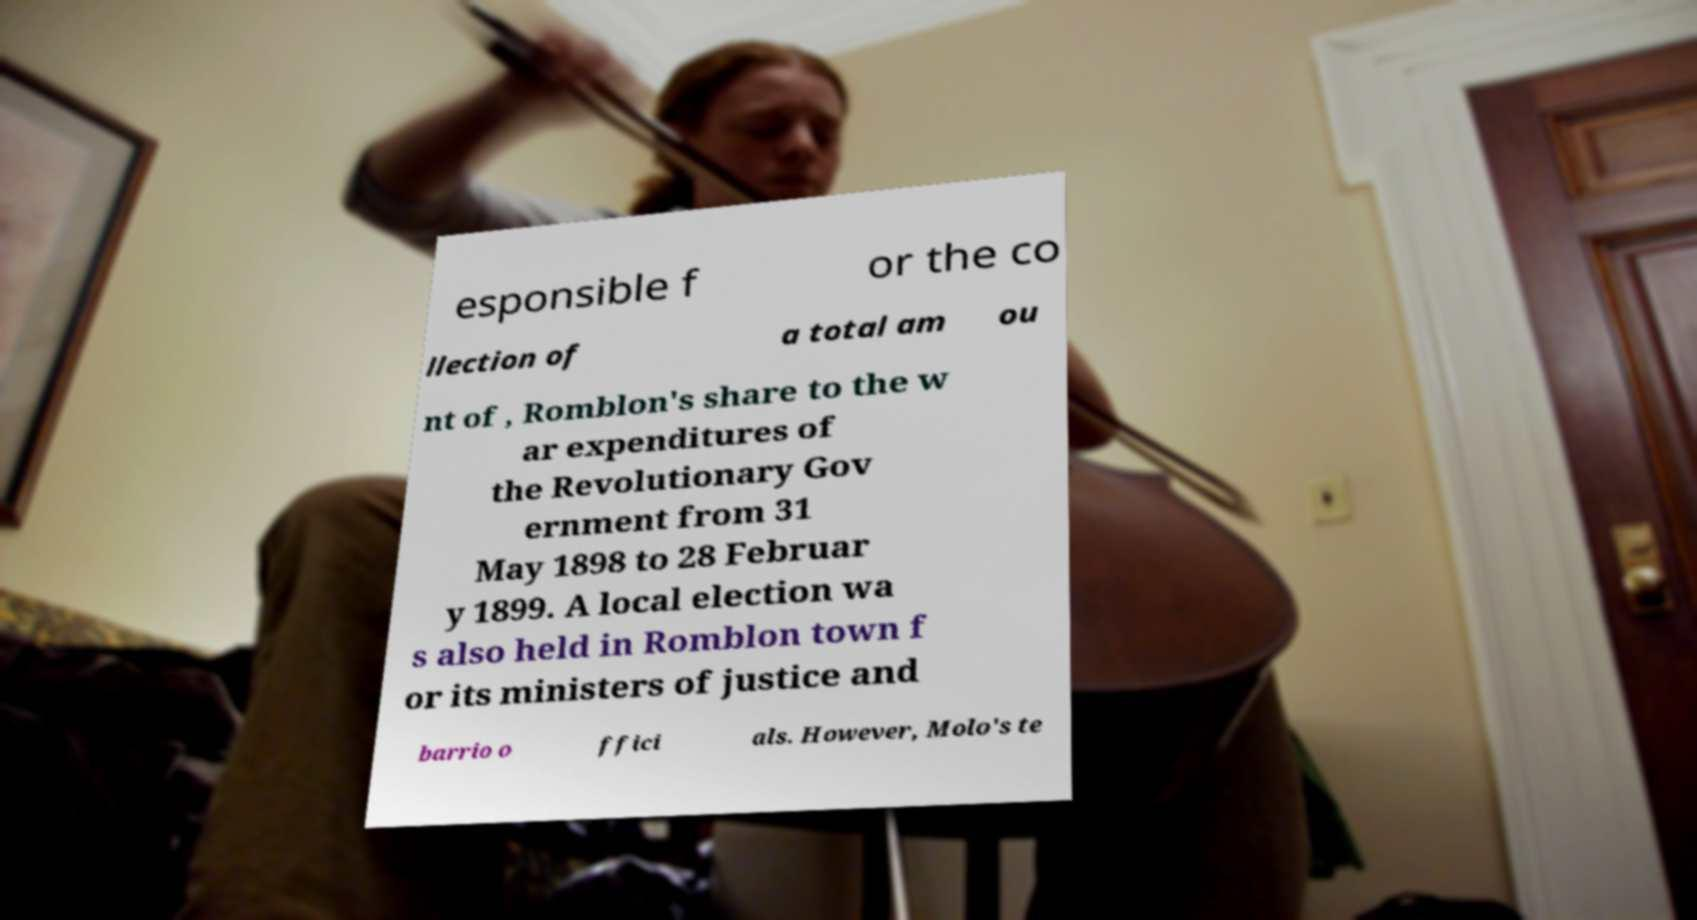Could you extract and type out the text from this image? esponsible f or the co llection of a total am ou nt of , Romblon's share to the w ar expenditures of the Revolutionary Gov ernment from 31 May 1898 to 28 Februar y 1899. A local election wa s also held in Romblon town f or its ministers of justice and barrio o ffici als. However, Molo's te 